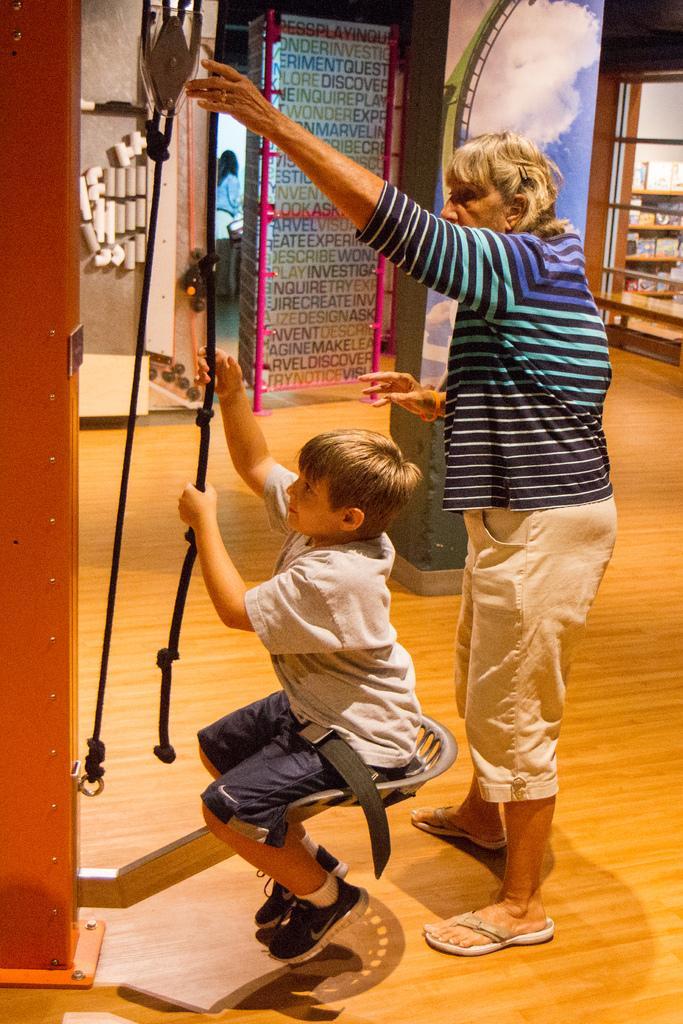Please provide a concise description of this image. This picture describes about few people, in the middle of the image we can see a boy, he is seated and he is holding a rope. 